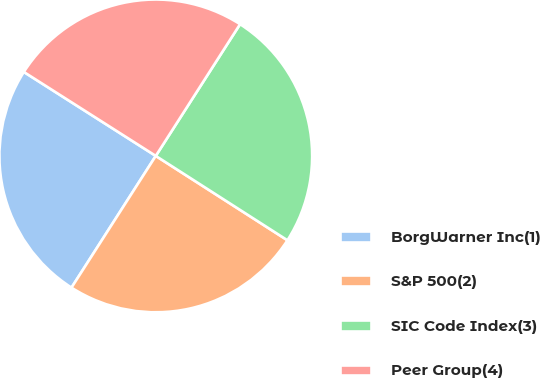<chart> <loc_0><loc_0><loc_500><loc_500><pie_chart><fcel>BorgWarner Inc(1)<fcel>S&P 500(2)<fcel>SIC Code Index(3)<fcel>Peer Group(4)<nl><fcel>24.96%<fcel>24.99%<fcel>25.01%<fcel>25.04%<nl></chart> 